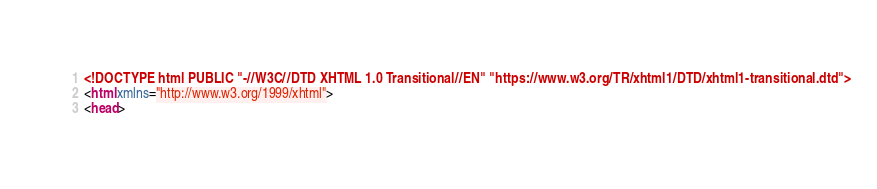<code> <loc_0><loc_0><loc_500><loc_500><_HTML_><!DOCTYPE html PUBLIC "-//W3C//DTD XHTML 1.0 Transitional//EN" "https://www.w3.org/TR/xhtml1/DTD/xhtml1-transitional.dtd">
<html xmlns="http://www.w3.org/1999/xhtml">
<head></code> 